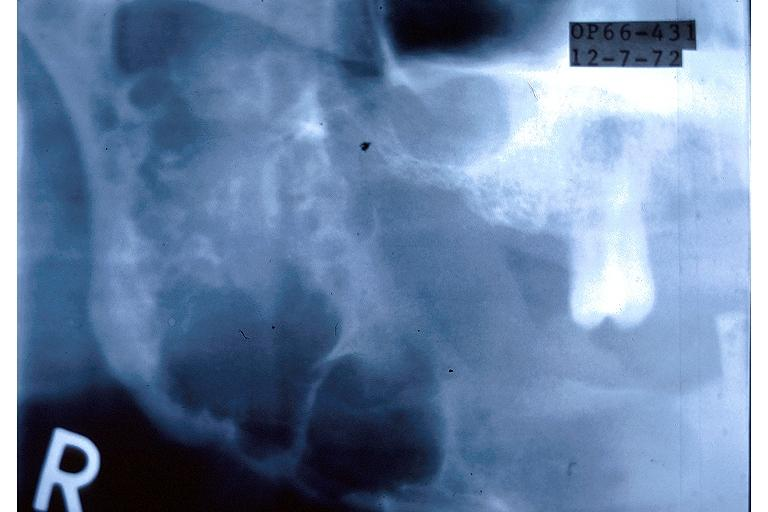where is this?
Answer the question using a single word or phrase. Oral 